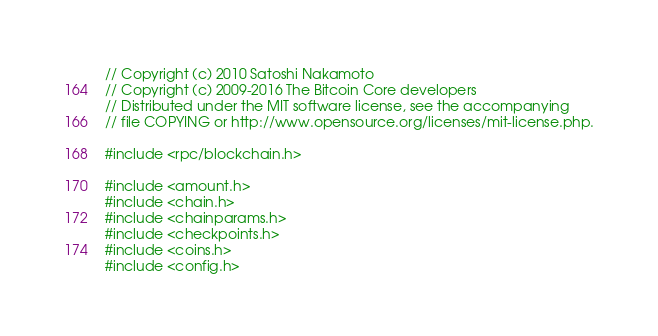Convert code to text. <code><loc_0><loc_0><loc_500><loc_500><_C++_>// Copyright (c) 2010 Satoshi Nakamoto
// Copyright (c) 2009-2016 The Bitcoin Core developers
// Distributed under the MIT software license, see the accompanying
// file COPYING or http://www.opensource.org/licenses/mit-license.php.

#include <rpc/blockchain.h>

#include <amount.h>
#include <chain.h>
#include <chainparams.h>
#include <checkpoints.h>
#include <coins.h>
#include <config.h></code> 